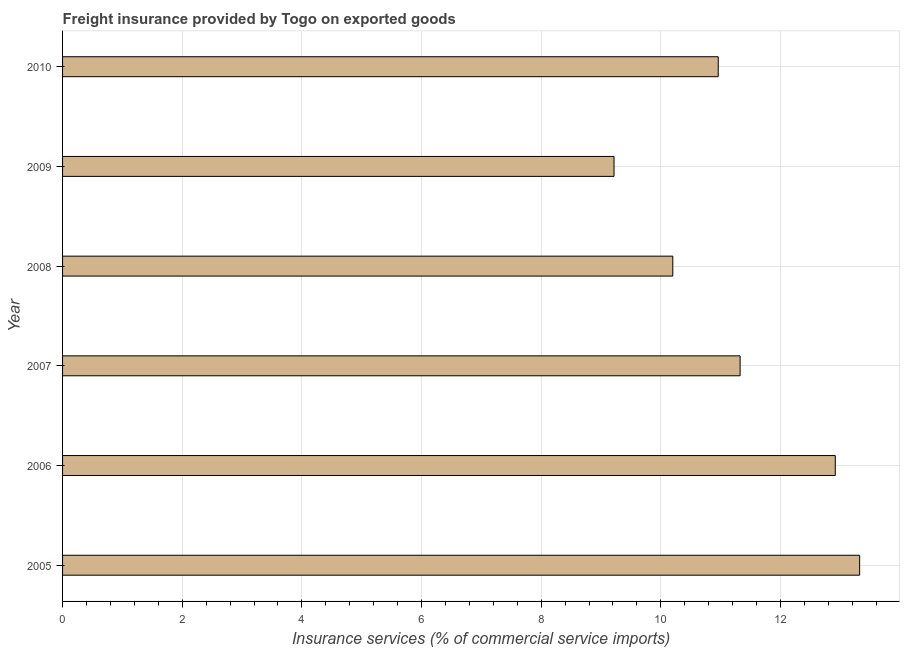Does the graph contain any zero values?
Your answer should be very brief. No. What is the title of the graph?
Give a very brief answer. Freight insurance provided by Togo on exported goods . What is the label or title of the X-axis?
Offer a terse response. Insurance services (% of commercial service imports). What is the freight insurance in 2008?
Offer a very short reply. 10.2. Across all years, what is the maximum freight insurance?
Make the answer very short. 13.32. Across all years, what is the minimum freight insurance?
Ensure brevity in your answer.  9.22. In which year was the freight insurance maximum?
Make the answer very short. 2005. What is the sum of the freight insurance?
Ensure brevity in your answer.  67.94. What is the difference between the freight insurance in 2006 and 2007?
Offer a terse response. 1.59. What is the average freight insurance per year?
Make the answer very short. 11.32. What is the median freight insurance?
Ensure brevity in your answer.  11.14. Do a majority of the years between 2007 and 2010 (inclusive) have freight insurance greater than 12.8 %?
Provide a succinct answer. No. What is the ratio of the freight insurance in 2005 to that in 2007?
Your answer should be very brief. 1.18. What is the difference between the highest and the second highest freight insurance?
Make the answer very short. 0.41. What is the difference between the highest and the lowest freight insurance?
Give a very brief answer. 4.11. What is the difference between two consecutive major ticks on the X-axis?
Your answer should be very brief. 2. What is the Insurance services (% of commercial service imports) in 2005?
Provide a short and direct response. 13.32. What is the Insurance services (% of commercial service imports) of 2006?
Your response must be concise. 12.92. What is the Insurance services (% of commercial service imports) in 2007?
Give a very brief answer. 11.33. What is the Insurance services (% of commercial service imports) in 2008?
Make the answer very short. 10.2. What is the Insurance services (% of commercial service imports) in 2009?
Offer a terse response. 9.22. What is the Insurance services (% of commercial service imports) of 2010?
Provide a succinct answer. 10.96. What is the difference between the Insurance services (% of commercial service imports) in 2005 and 2006?
Keep it short and to the point. 0.41. What is the difference between the Insurance services (% of commercial service imports) in 2005 and 2007?
Provide a short and direct response. 2. What is the difference between the Insurance services (% of commercial service imports) in 2005 and 2008?
Make the answer very short. 3.12. What is the difference between the Insurance services (% of commercial service imports) in 2005 and 2009?
Your response must be concise. 4.11. What is the difference between the Insurance services (% of commercial service imports) in 2005 and 2010?
Make the answer very short. 2.36. What is the difference between the Insurance services (% of commercial service imports) in 2006 and 2007?
Give a very brief answer. 1.59. What is the difference between the Insurance services (% of commercial service imports) in 2006 and 2008?
Provide a succinct answer. 2.72. What is the difference between the Insurance services (% of commercial service imports) in 2006 and 2009?
Your answer should be very brief. 3.7. What is the difference between the Insurance services (% of commercial service imports) in 2006 and 2010?
Offer a terse response. 1.96. What is the difference between the Insurance services (% of commercial service imports) in 2007 and 2008?
Provide a succinct answer. 1.13. What is the difference between the Insurance services (% of commercial service imports) in 2007 and 2009?
Provide a succinct answer. 2.11. What is the difference between the Insurance services (% of commercial service imports) in 2007 and 2010?
Offer a very short reply. 0.37. What is the difference between the Insurance services (% of commercial service imports) in 2008 and 2009?
Ensure brevity in your answer.  0.98. What is the difference between the Insurance services (% of commercial service imports) in 2008 and 2010?
Make the answer very short. -0.76. What is the difference between the Insurance services (% of commercial service imports) in 2009 and 2010?
Provide a short and direct response. -1.74. What is the ratio of the Insurance services (% of commercial service imports) in 2005 to that in 2006?
Offer a very short reply. 1.03. What is the ratio of the Insurance services (% of commercial service imports) in 2005 to that in 2007?
Provide a short and direct response. 1.18. What is the ratio of the Insurance services (% of commercial service imports) in 2005 to that in 2008?
Make the answer very short. 1.31. What is the ratio of the Insurance services (% of commercial service imports) in 2005 to that in 2009?
Your response must be concise. 1.45. What is the ratio of the Insurance services (% of commercial service imports) in 2005 to that in 2010?
Offer a terse response. 1.22. What is the ratio of the Insurance services (% of commercial service imports) in 2006 to that in 2007?
Your answer should be very brief. 1.14. What is the ratio of the Insurance services (% of commercial service imports) in 2006 to that in 2008?
Offer a very short reply. 1.27. What is the ratio of the Insurance services (% of commercial service imports) in 2006 to that in 2009?
Your answer should be compact. 1.4. What is the ratio of the Insurance services (% of commercial service imports) in 2006 to that in 2010?
Provide a succinct answer. 1.18. What is the ratio of the Insurance services (% of commercial service imports) in 2007 to that in 2008?
Make the answer very short. 1.11. What is the ratio of the Insurance services (% of commercial service imports) in 2007 to that in 2009?
Keep it short and to the point. 1.23. What is the ratio of the Insurance services (% of commercial service imports) in 2007 to that in 2010?
Keep it short and to the point. 1.03. What is the ratio of the Insurance services (% of commercial service imports) in 2008 to that in 2009?
Offer a terse response. 1.11. What is the ratio of the Insurance services (% of commercial service imports) in 2008 to that in 2010?
Keep it short and to the point. 0.93. What is the ratio of the Insurance services (% of commercial service imports) in 2009 to that in 2010?
Your response must be concise. 0.84. 